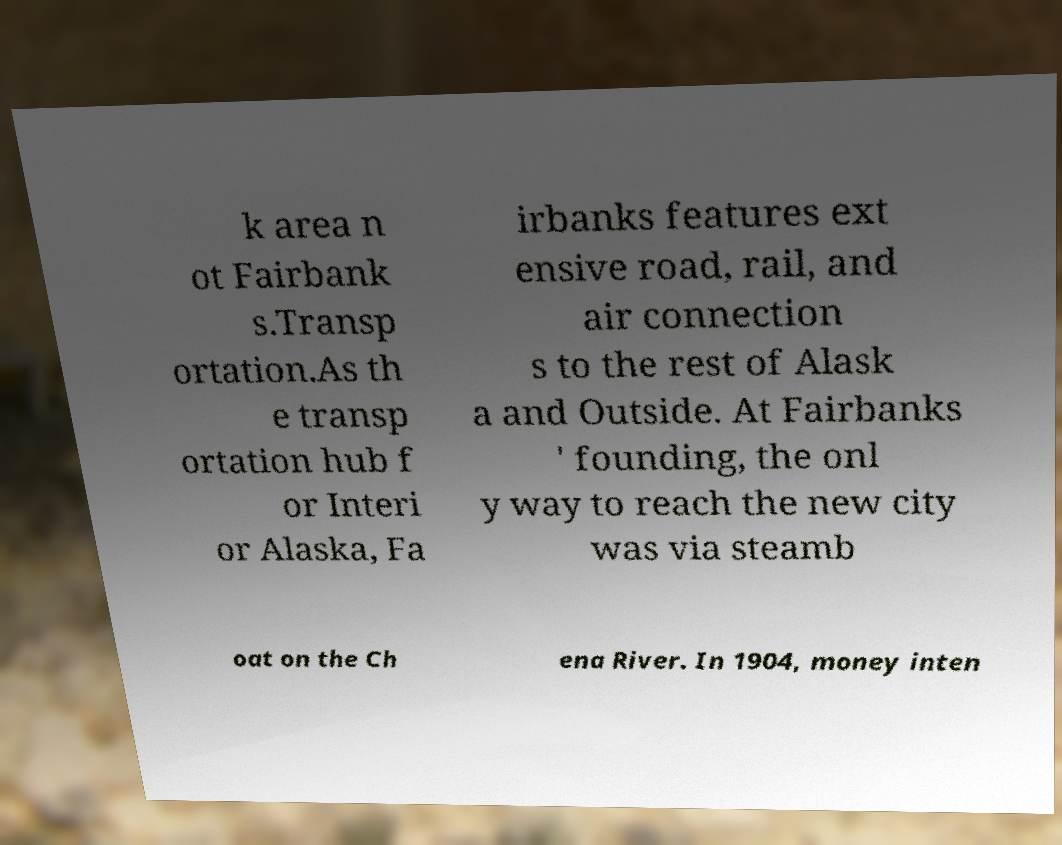Could you extract and type out the text from this image? k area n ot Fairbank s.Transp ortation.As th e transp ortation hub f or Interi or Alaska, Fa irbanks features ext ensive road, rail, and air connection s to the rest of Alask a and Outside. At Fairbanks ' founding, the onl y way to reach the new city was via steamb oat on the Ch ena River. In 1904, money inten 